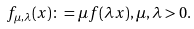<formula> <loc_0><loc_0><loc_500><loc_500>f _ { \mu , \lambda } ( x ) \colon = \mu f ( \lambda x ) , \mu , \lambda > 0 .</formula> 